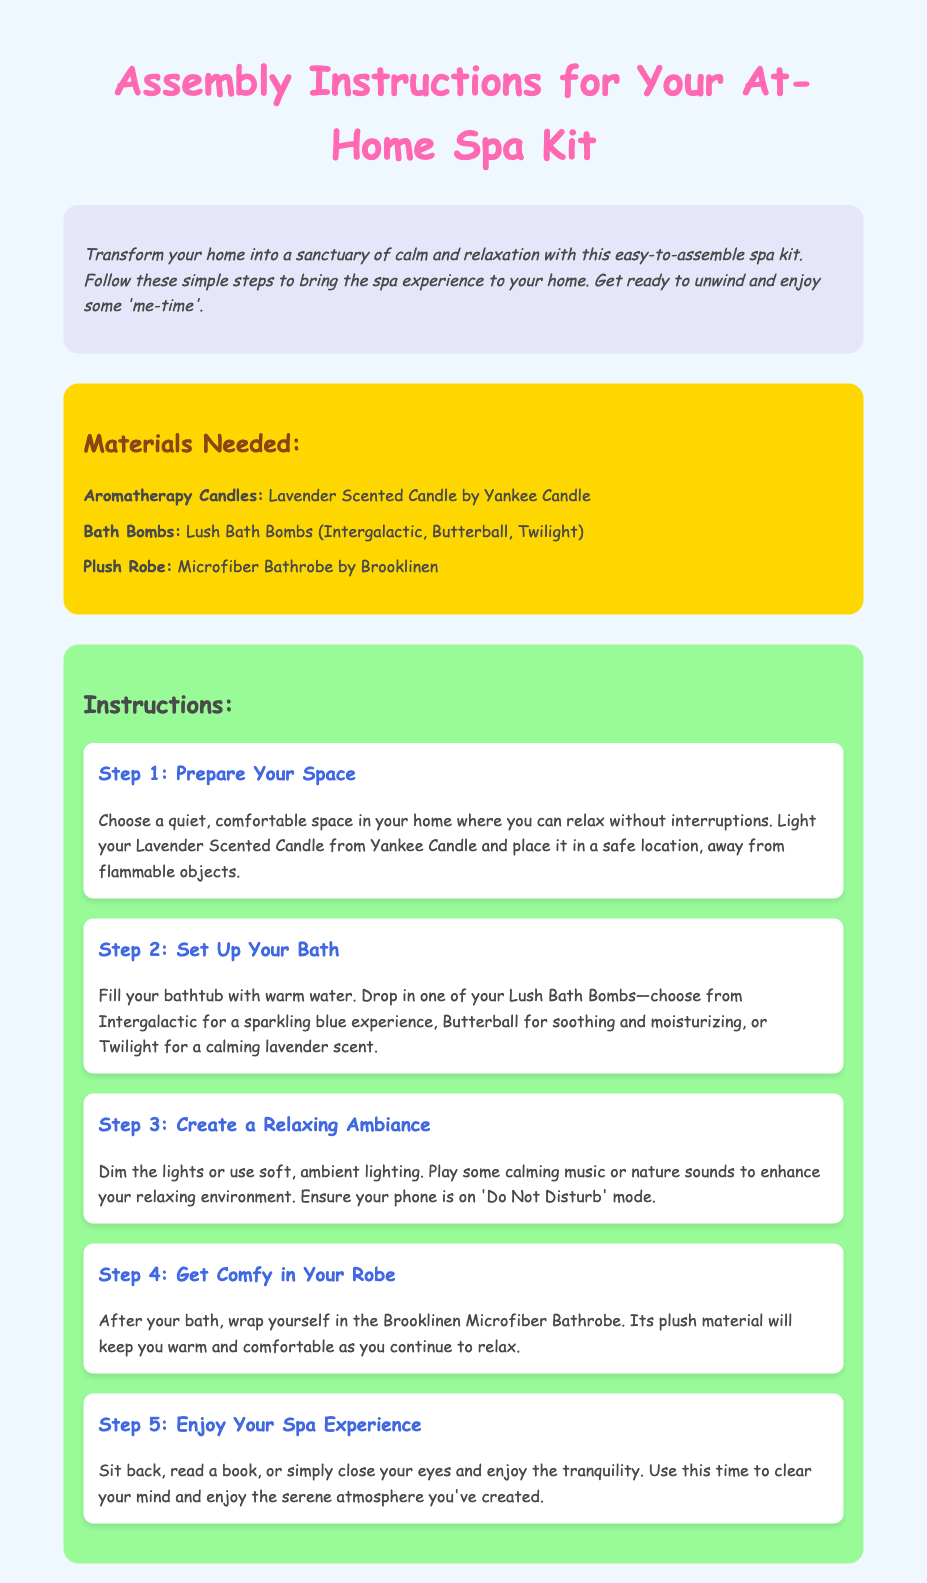What is the title of the document? The title is presented at the top of the document as the main header.
Answer: Assembly Instructions for Your At-Home Spa Kit What scented candle is included in the materials? The specific scented candle is listed under the materials needed section.
Answer: Lavender Scented Candle by Yankee Candle How many Lush Bath Bombs are mentioned? The number of specific bath bombs is highlighted in the list of materials.
Answer: Three What is the main color theme of the document's background? The background color of the document is described in the style section.
Answer: Light blue What is recommended for creating a relaxing ambiance? The instructions detail how to enhance the relaxation experience in the space.
Answer: Dim the lights Which brand is the plush robe from? The brand of the plush robe is found in the materials needed section.
Answer: Brooklinen What is step 2 about? The steps section provides a brief overview of the purpose of step 2 in the assembly.
Answer: Set Up Your Bath What should you do after the bath? The instruction indicates what to do after completing the bath step.
Answer: Get Comfy in Your Robe How should the phone be set during the spa experience? The instructions mention a specific setting for the phone to enhance relaxation.
Answer: Do Not Disturb mode 